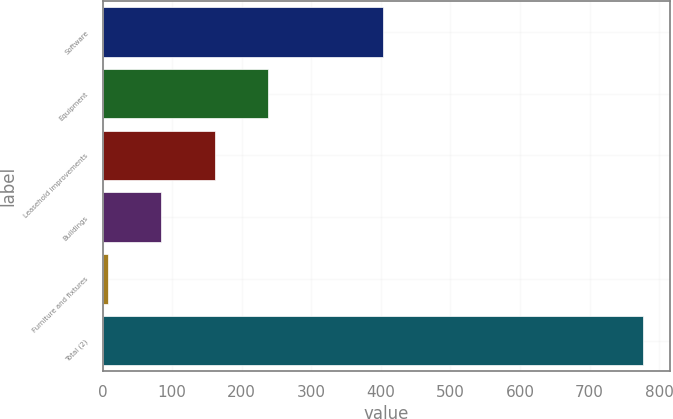Convert chart to OTSL. <chart><loc_0><loc_0><loc_500><loc_500><bar_chart><fcel>Software<fcel>Equipment<fcel>Leasehold improvements<fcel>Buildings<fcel>Furniture and fixtures<fcel>Total (2)<nl><fcel>403<fcel>238<fcel>161<fcel>84<fcel>7<fcel>777<nl></chart> 